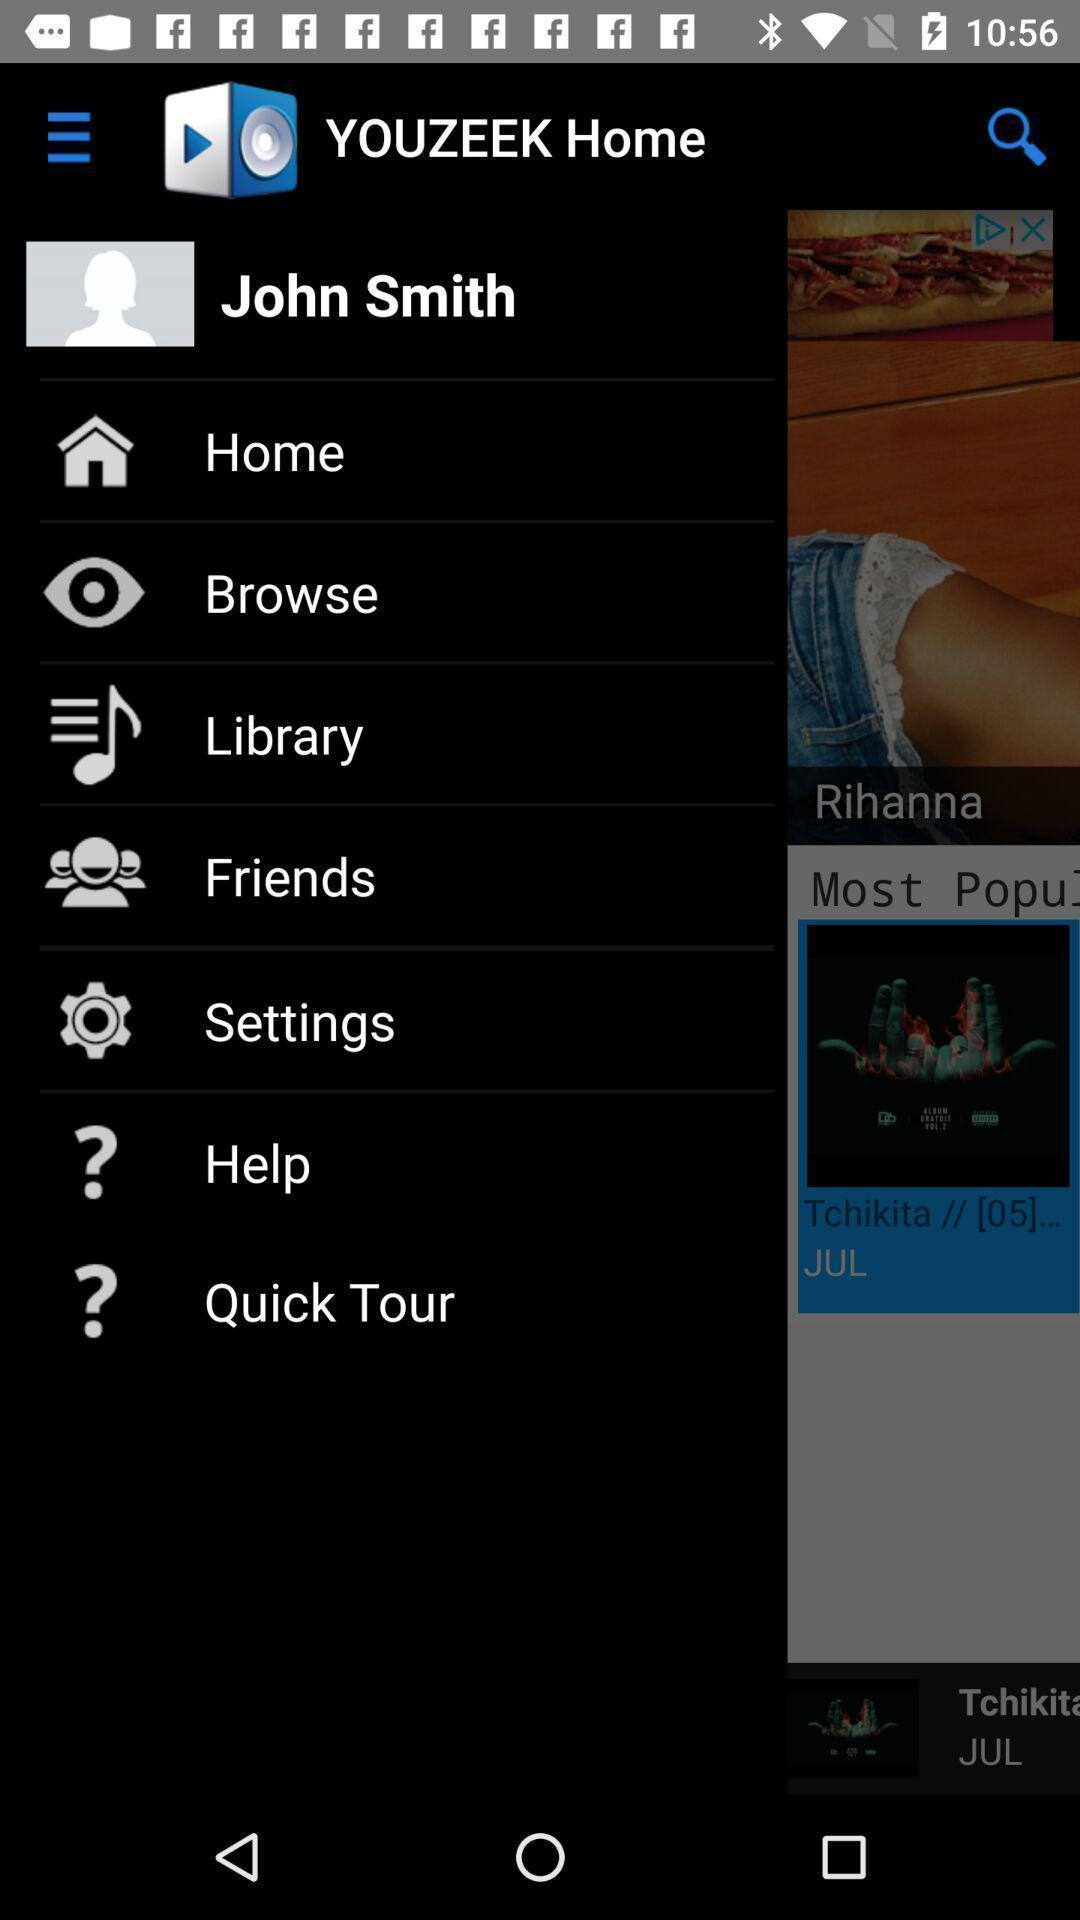Describe the content in this image. Page showing menu options of music app. 